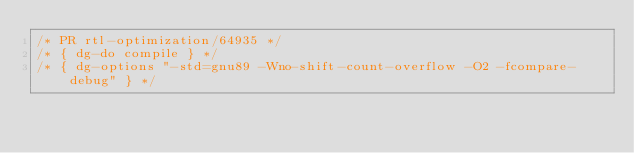Convert code to text. <code><loc_0><loc_0><loc_500><loc_500><_C_>/* PR rtl-optimization/64935 */
/* { dg-do compile } */
/* { dg-options "-std=gnu89 -Wno-shift-count-overflow -O2 -fcompare-debug" } */</code> 